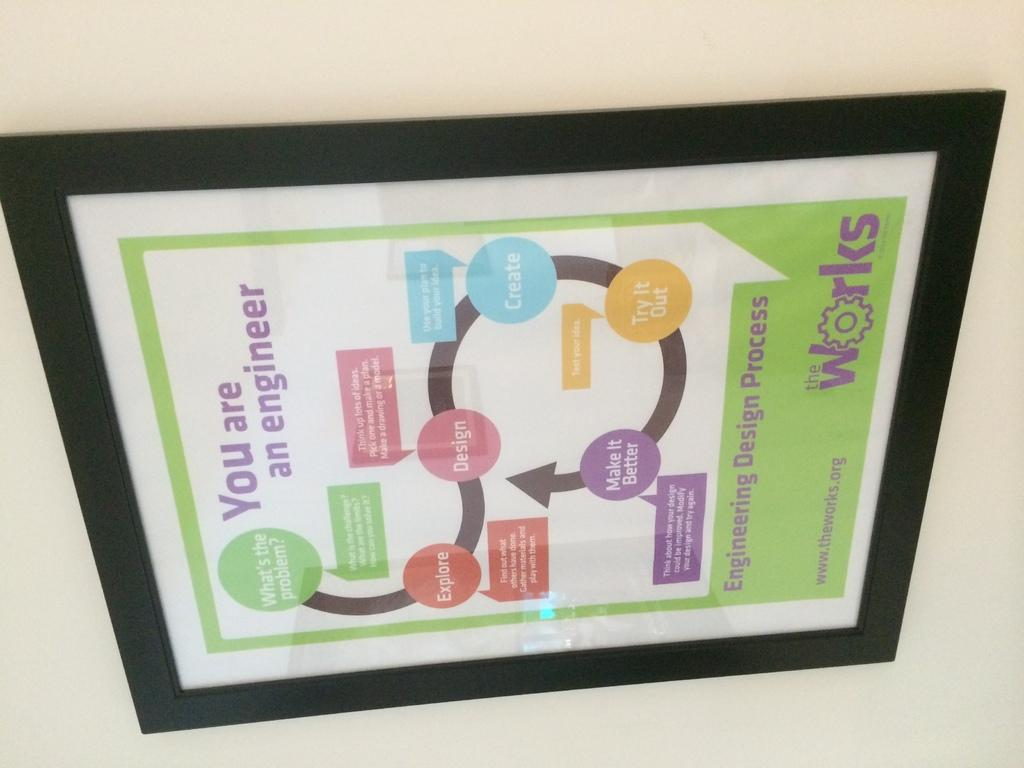<image>
Render a clear and concise summary of the photo. A sign for The Works says that "you are an engineer" 